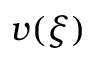Convert formula to latex. <formula><loc_0><loc_0><loc_500><loc_500>v ( \xi )</formula> 